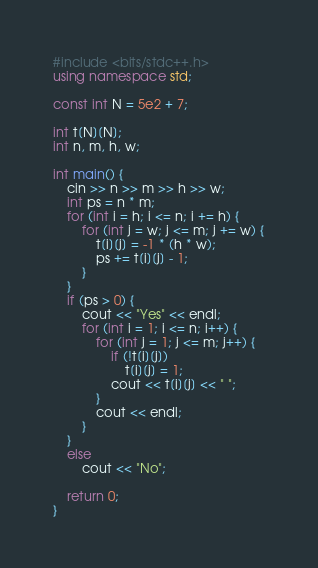<code> <loc_0><loc_0><loc_500><loc_500><_C++_>#include <bits/stdc++.h>
using namespace std;

const int N = 5e2 + 7;

int t[N][N];
int n, m, h, w;

int main() {
	cin >> n >> m >> h >> w;
	int ps = n * m;
	for (int i = h; i <= n; i += h) {
		for (int j = w; j <= m; j += w) {
			t[i][j] = -1 * (h * w);
			ps += t[i][j] - 1;
		}
	}
	if (ps > 0) {
		cout << "Yes" << endl;
		for (int i = 1; i <= n; i++) {
			for (int j = 1; j <= m; j++) {
				if (!t[i][j])
					t[i][j] = 1;
				cout << t[i][j] << " ";
			}
			cout << endl;
		}
	}
	else
		cout << "No";

	return 0;
}
</code> 